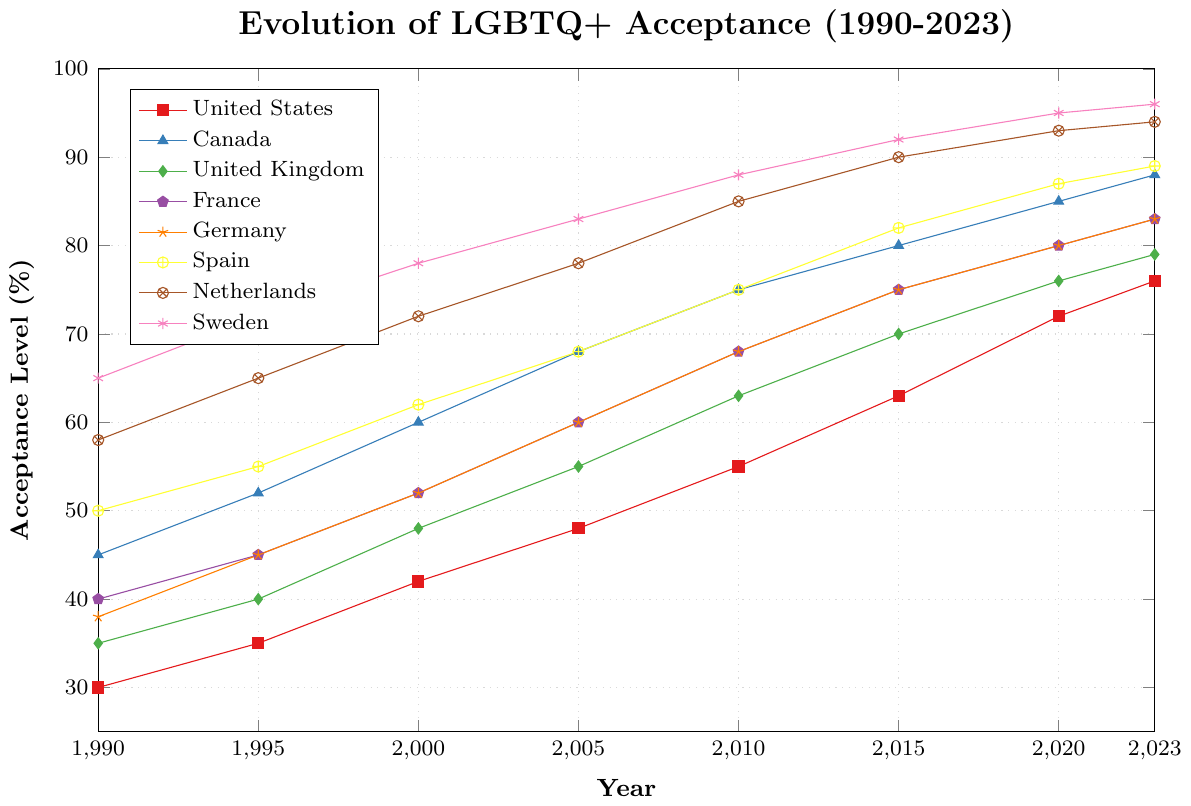What is the acceptance level for LGBTQ+ rights in Sweden in the year 2000? In the figure, locate the line representing Sweden and find the data point for the year 2000. The acceptance level in Sweden for that year is 78.
Answer: 78 Which country had the highest acceptance level of LGBTQ+ rights in 2023? Compare the heights of the data points for all the countries in the year 2023. Sweden has the highest acceptance level at 96%.
Answer: Sweden Did the acceptance level of LGBTQ+ rights in the United States surpass 50% before 2005? Look at the trend line for the United States. The acceptance level was 30% in 1990, 35% in 1995, 42% in 2000, and 48% in 2005. It did not surpass 50% before 2005.
Answer: No What was the average acceptance level across all countries in the year 2015? Sum the acceptance levels for all countries in 2015 and divide by the number of countries: (63+80+70+75+75+82+90+92)/8 = 78.375.
Answer: 78.375 Which country showed the steepest increase in LGBTQ+ acceptance between 1990 and 2023? Calculate the difference in acceptance levels between 2023 and 1990 for each country. Sweden increased from 65% to 96%, making it the steepest increase of 31%.
Answer: Sweden What is the difference in acceptance level between Canada and the United Kingdom in 2020? Find the data points for Canada and the United Kingdom in 2020. Canada has 85% and the United Kingdom has 76%. The difference is 85% - 76% = 9%.
Answer: 9% Between 1990 and 2023, did Germany ever have the highest acceptance level in any given year? Compare Germany's acceptance levels in each year to the acceptance levels of the other countries. Germany never had the highest acceptance level in any given year.
Answer: No In which year did Spain's acceptance level reach 82%? Find the data point where Spain's acceptance level is 82%. It reached 82% in 2015.
Answer: 2015 